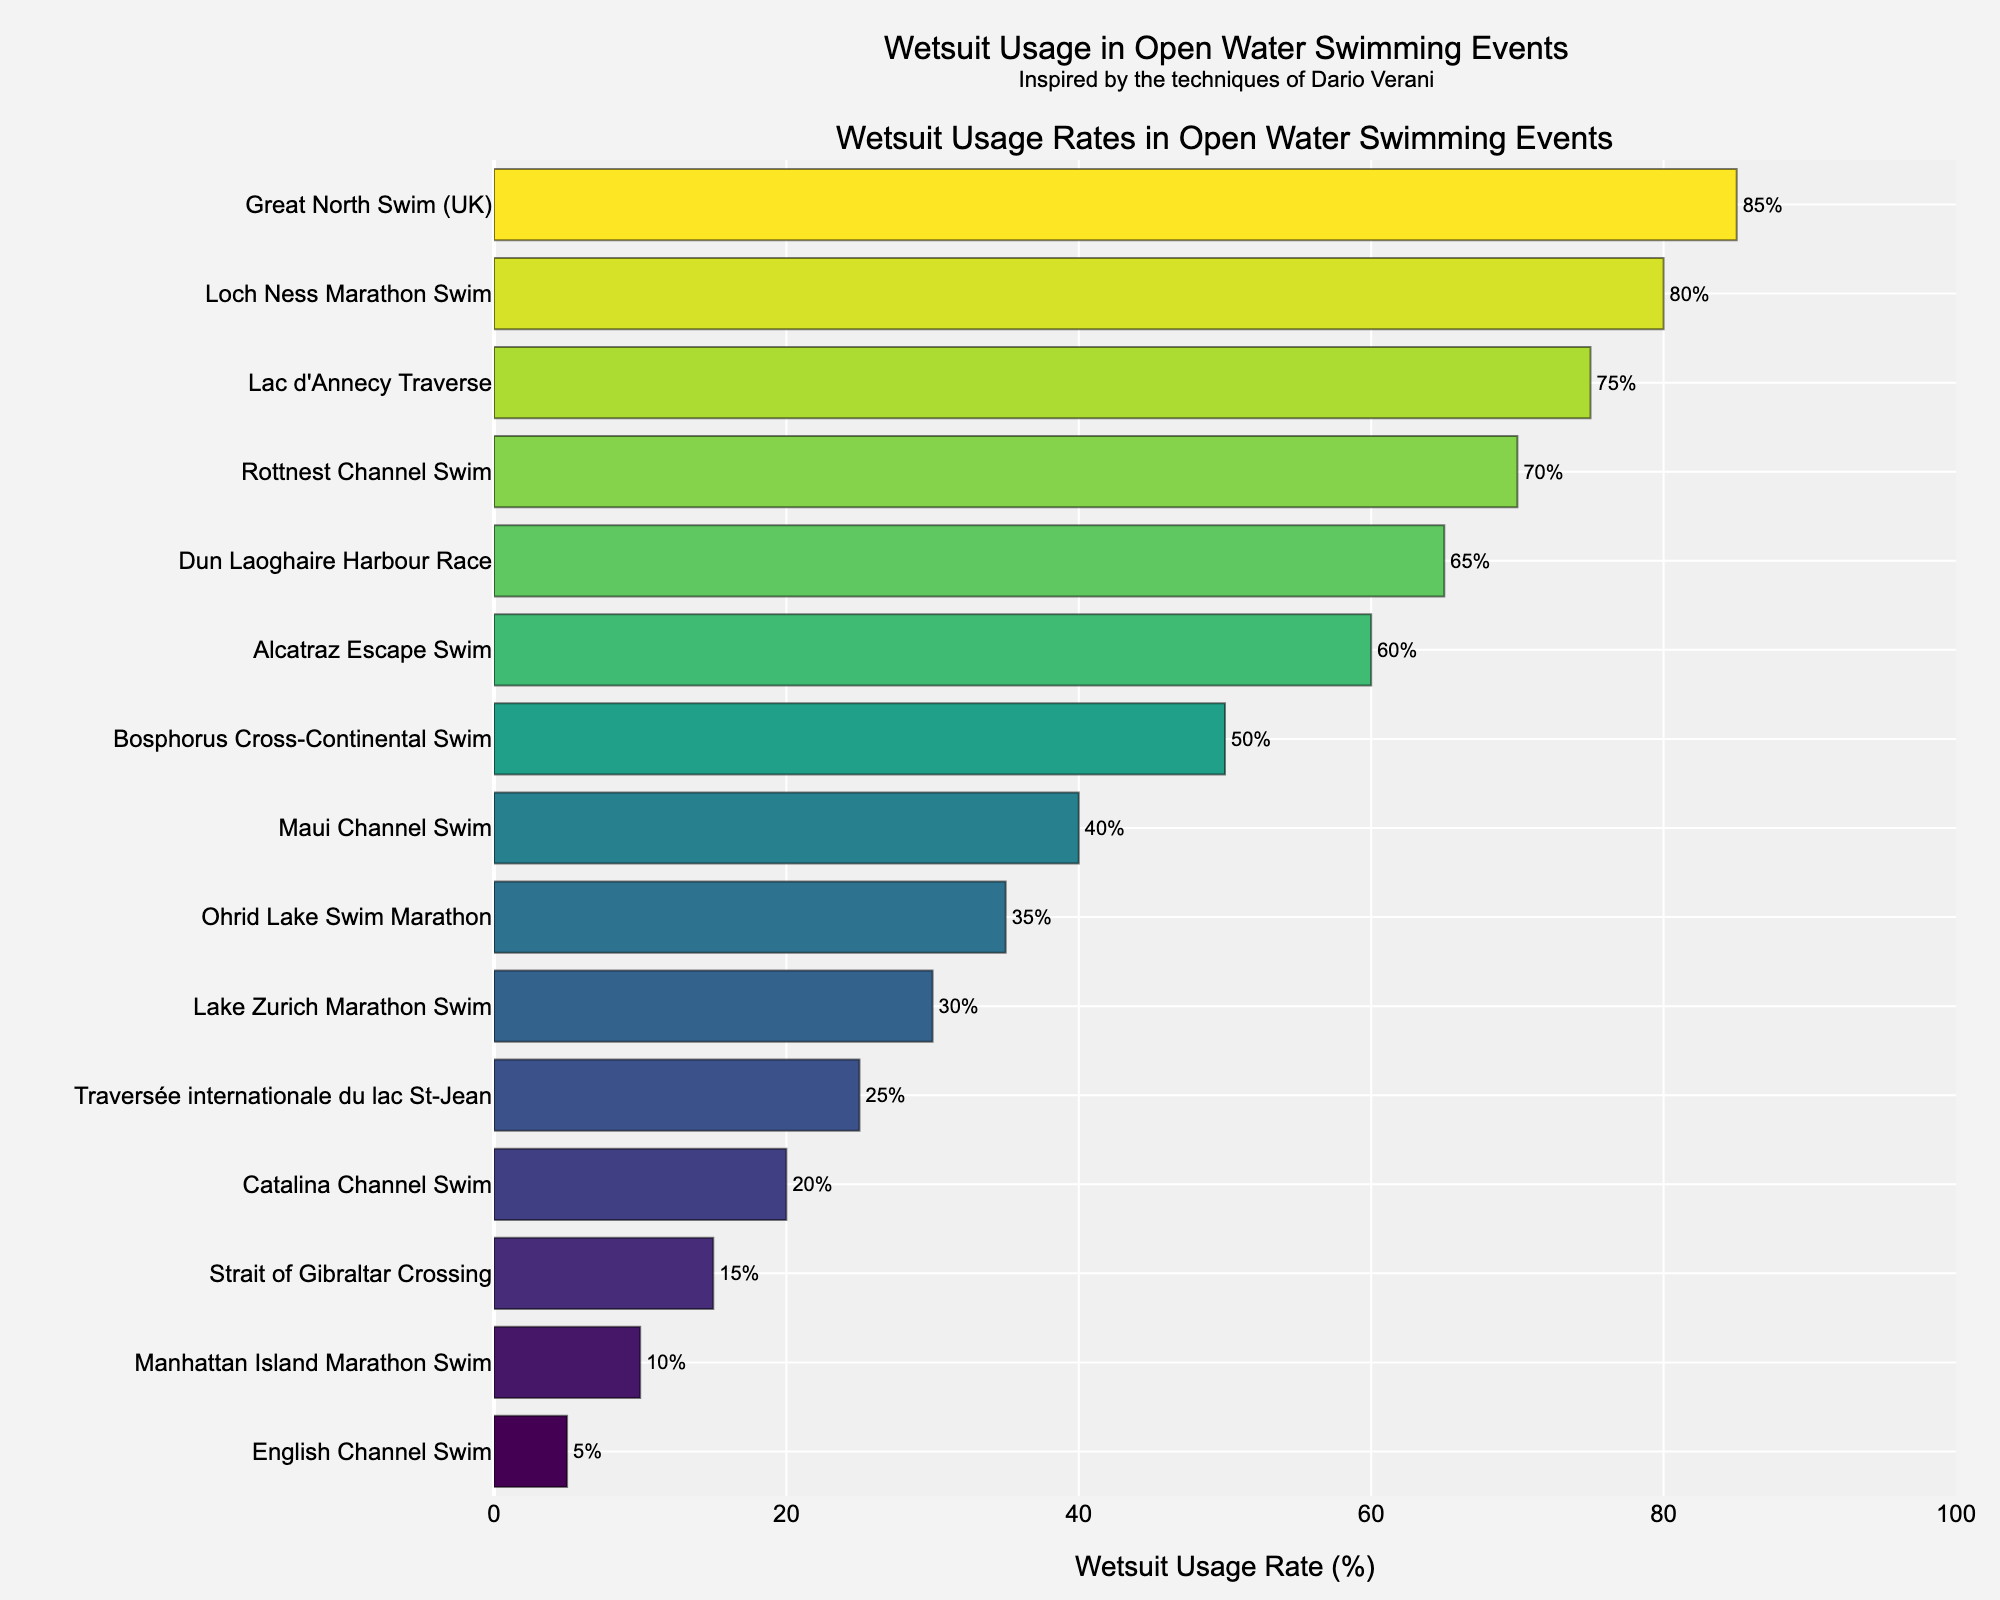Which event has the highest wetsuit usage rate? Identify the bar with the highest value in the horizontal bar chart. The event with the highest wetsuit usage rate will have the tallest bar.
Answer: Great North Swim (UK) Which event has the lowest wetsuit usage rate? Identify the bar with the lowest value in the horizontal bar chart. The event with the lowest wetsuit usage rate will have the shortest bar.
Answer: English Channel Swim How many events have a wetsuit usage rate of 50% or higher? Count the number of bars that extend to 50% or more on the x-axis.
Answer: 8 What is the average wetsuit usage rate for the Manhattan Island Marathon Swim, Catalina Channel Swim, and Lake Zurich Marathon Swim? Add the usage rates of these events and divide by the number of events: (10% + 20% + 30%) / 3 = 60% / 3 = 20%.
Answer: 20% Which event has a wetsuit usage rate closest to 40%? Look for the bar that most closely aligns with the 40% mark on the x-axis.
Answer: Maui Channel Swim How much higher is the wetsuit usage rate for the Loch Ness Marathon Swim compared to the Alcatraz Escape Swim? Calculate the difference between the usage rates: 80% - 60% = 20%.
Answer: 20% Arrange the events in descending order of wetsuit usage rate. List events from the highest to the lowest based on the bar lengths: Great North Swim (UK), Loch Ness Marathon Swim, Lac d'Annecy Traverse, Rottnest Channel Swim, Dun Laoghaire Harbour Race, Alcatraz Escape Swim, Bosphorus Cross-Continental Swim, Maui Channel Swim, Ohrid Lake Swim Marathon, Lake Zurich Marathon Swim, Traversée internationale du lac St-Jean, Catalina Channel Swim, Strait of Gibraltar Crossing, Manhattan Island Marathon Swim, English Channel Swim.
Answer: Great North Swim (UK), Loch Ness Marathon Swim, Lac d'Annecy Traverse, Rottnest Channel Swim, Dun Laoghaire Harbour Race, Alcatraz Escape Swim, Bosphorus Cross-Continental Swim, Maui Channel Swim, Ohrid Lake Swim Marathon, Lake Zurich Marathon Swim, Traversée internationale du lac St-Jean, Catalina Channel Swim, Strait of Gibraltar Crossing, Manhattan Island Marathon Swim, English Channel Swim What is the median wetsuit usage rate across all events? Arrange the usage rates in numerical order and find the middle value: 5, 10, 15, 20, 25, 30, 35, 40, 50, 60, 65, 70, 75, 80, 85. The median is the middle number of this sorted list, which is 50%.
Answer: 50% Compare the wetsuit usage rates of the Rottnest Channel Swim and the Dun Laoghaire Harbour Race. Which one is higher and by how much? The Rottnest Channel Swim has a usage rate of 70%, while Dun Laoghaire Harbour Race has 65%. The difference is 70% - 65% = 5%.
Answer: Rottnest Channel Swim by 5% What is the combined wetsuit usage rate for the English Channel Swim, Bosphorus Cross-Continental Swim, and Loch Ness Marathon Swim? Add the usage rates of these events: 5% + 50% + 80% = 135%.
Answer: 135% 